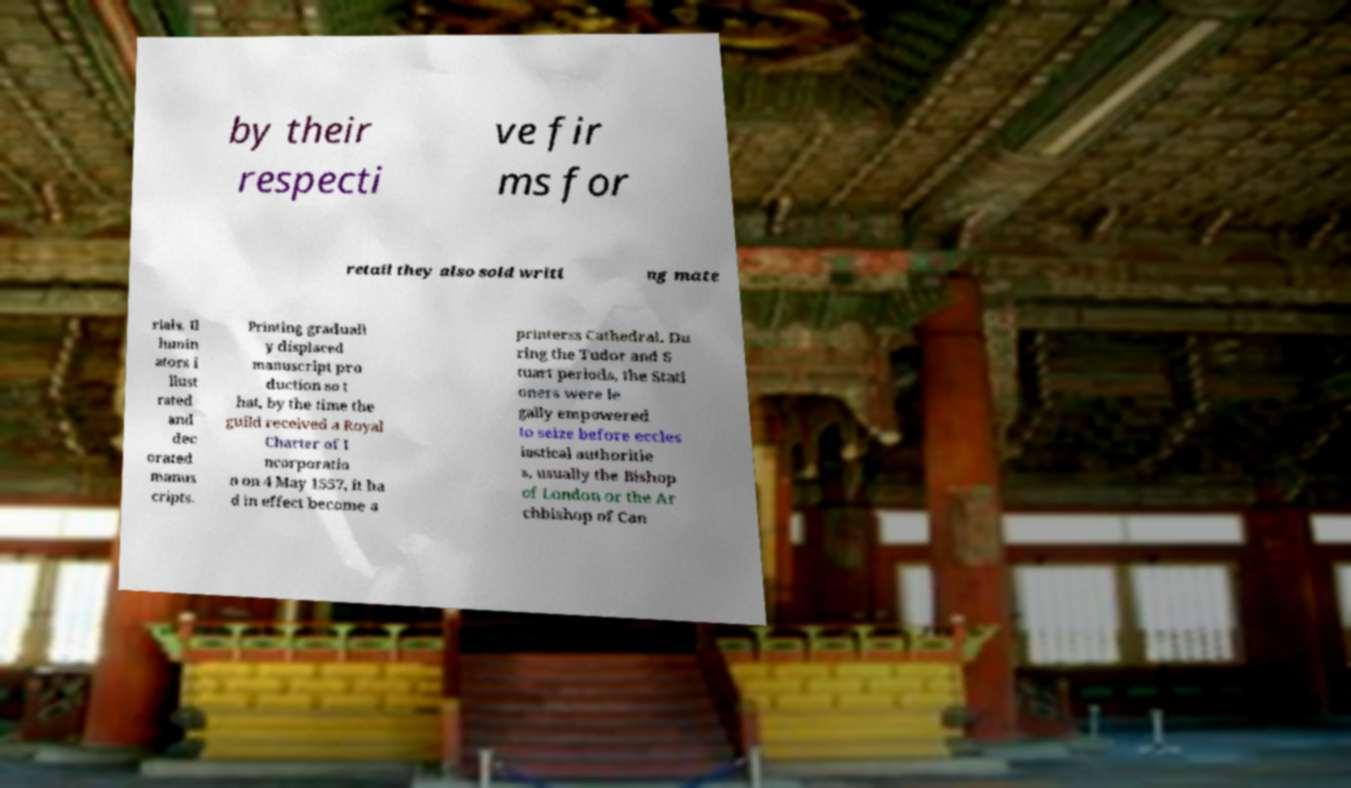Can you read and provide the text displayed in the image?This photo seems to have some interesting text. Can you extract and type it out for me? by their respecti ve fir ms for retail they also sold writi ng mate rials. Il lumin ators i llust rated and dec orated manus cripts. Printing graduall y displaced manuscript pro duction so t hat, by the time the guild received a Royal Charter of I ncorporatio n on 4 May 1557, it ha d in effect become a printerss Cathedral. Du ring the Tudor and S tuart periods, the Stati oners were le gally empowered to seize before eccles iastical authoritie s, usually the Bishop of London or the Ar chbishop of Can 